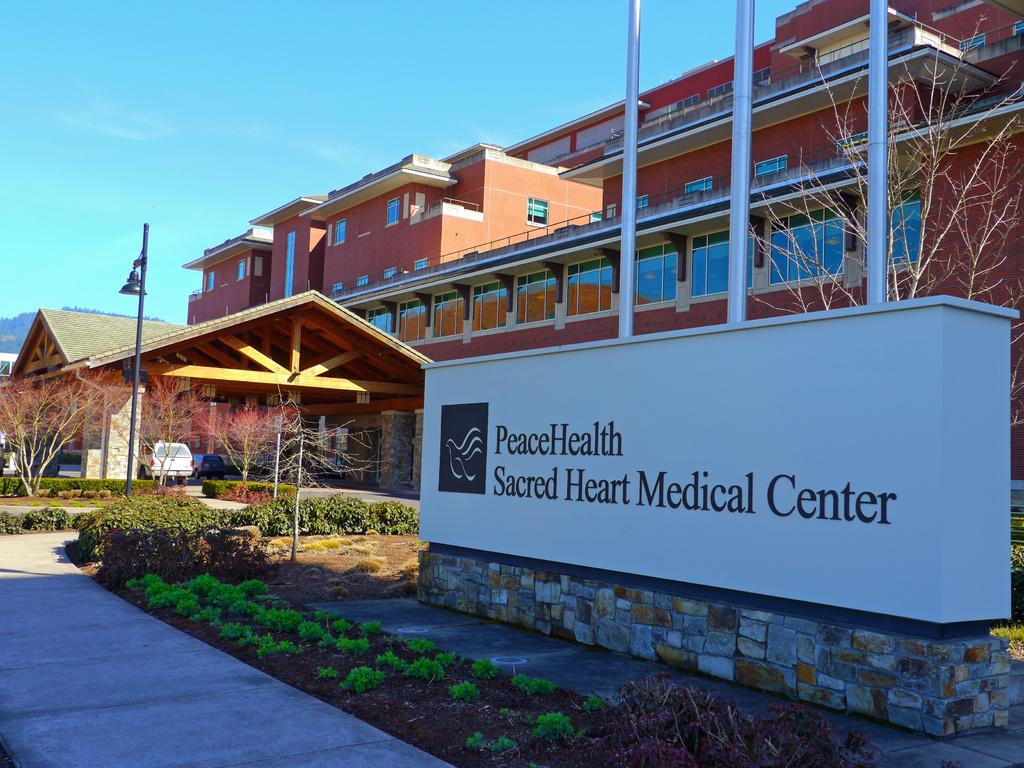What type of structures can be seen in the image? There are buildings in the image. What natural elements are present in the image? There are trees and plants in the image. What man-made objects can be seen in the image? There are vehicles and poles in the image. What is written on in the image? There is something written on a white object in the image. What can be seen in the background of the image? The sky is visible in the background of the image. Can you tell me how many bears are sitting on the vehicles in the image? There are no bears present in the image; it features buildings, trees, plants, vehicles, poles, a white object with writing, and the sky. What thought is being expressed by the substance in the image? There is no substance or thought present in the image. 